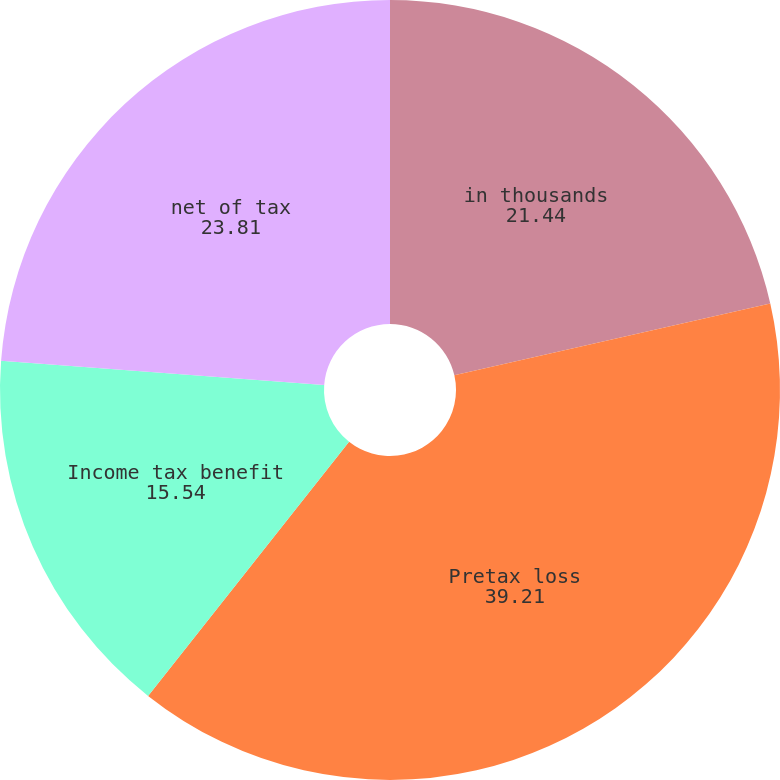Convert chart. <chart><loc_0><loc_0><loc_500><loc_500><pie_chart><fcel>in thousands<fcel>Pretax loss<fcel>Income tax benefit<fcel>net of tax<nl><fcel>21.44%<fcel>39.21%<fcel>15.54%<fcel>23.81%<nl></chart> 